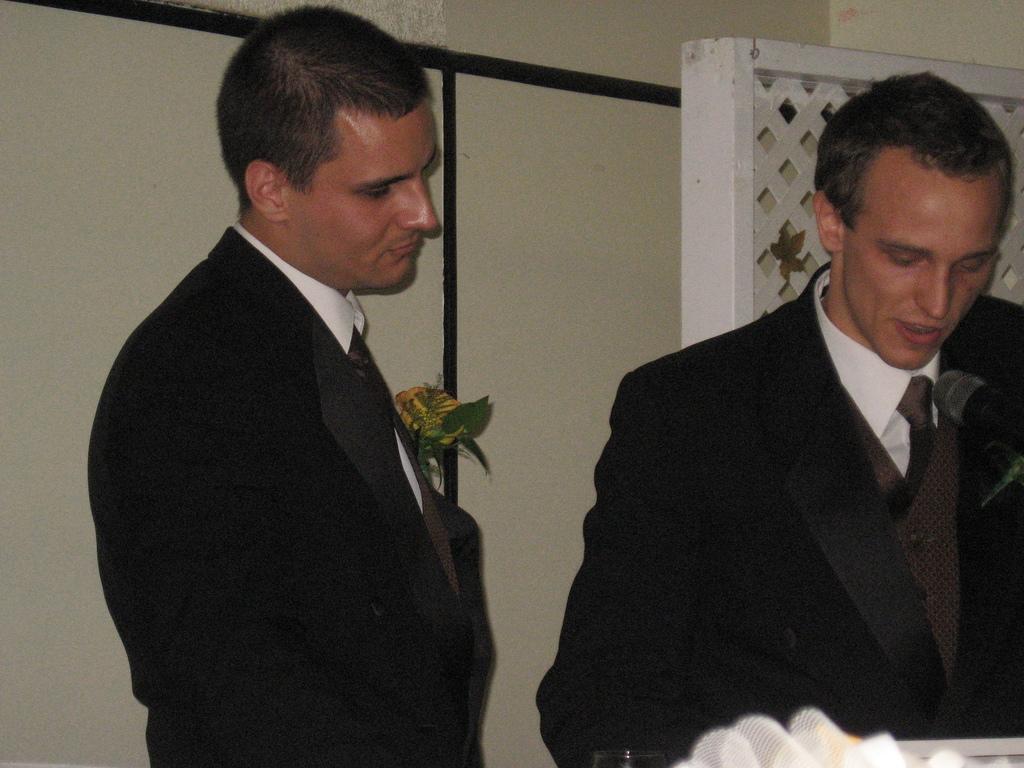In one or two sentences, can you explain what this image depicts? In this picture we can see two men, they wore black color suits, behind them we can see a plant. 